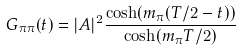<formula> <loc_0><loc_0><loc_500><loc_500>G _ { \pi \pi } ( t ) = | A | ^ { 2 } \frac { \cosh ( m _ { \pi } ( T / 2 - t ) ) } { \cosh ( m _ { \pi } T / 2 ) }</formula> 